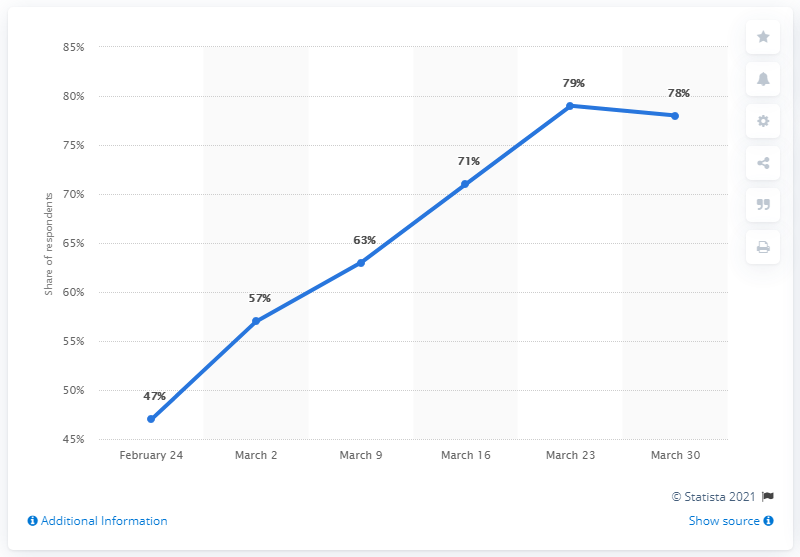Identify some key points in this picture. The sum of the two highest peaks is 157. On March 23, the highest peak of support for the blockade was reached. 